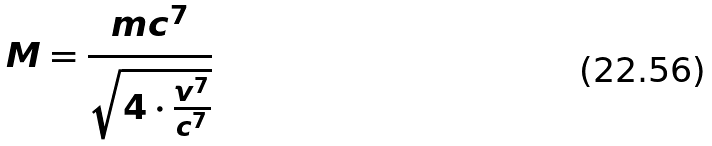<formula> <loc_0><loc_0><loc_500><loc_500>M = \frac { m c ^ { 7 } } { \sqrt { 4 \cdot \frac { v ^ { 7 } } { c ^ { 7 } } } }</formula> 